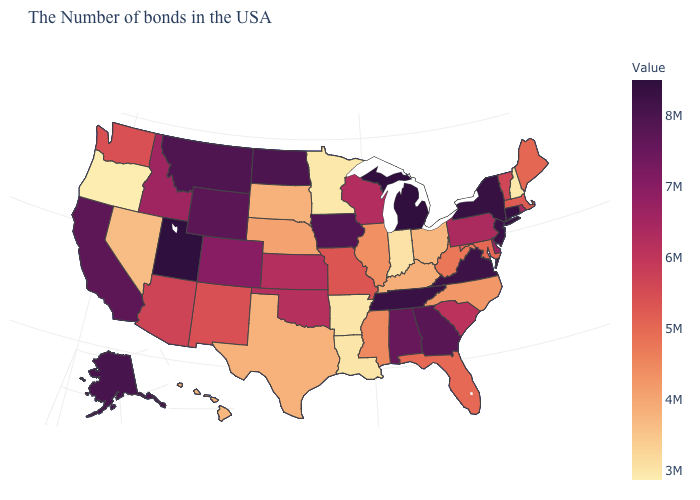Is the legend a continuous bar?
Concise answer only. Yes. Among the states that border Virginia , does Tennessee have the highest value?
Quick response, please. Yes. Which states hav the highest value in the MidWest?
Give a very brief answer. Michigan. 